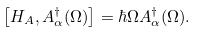<formula> <loc_0><loc_0><loc_500><loc_500>\left [ H _ { A } , A _ { \alpha } ^ { \dagger } ( \Omega ) \right ] = \hbar { \Omega } A _ { \alpha } ^ { \dagger } ( \Omega ) .</formula> 